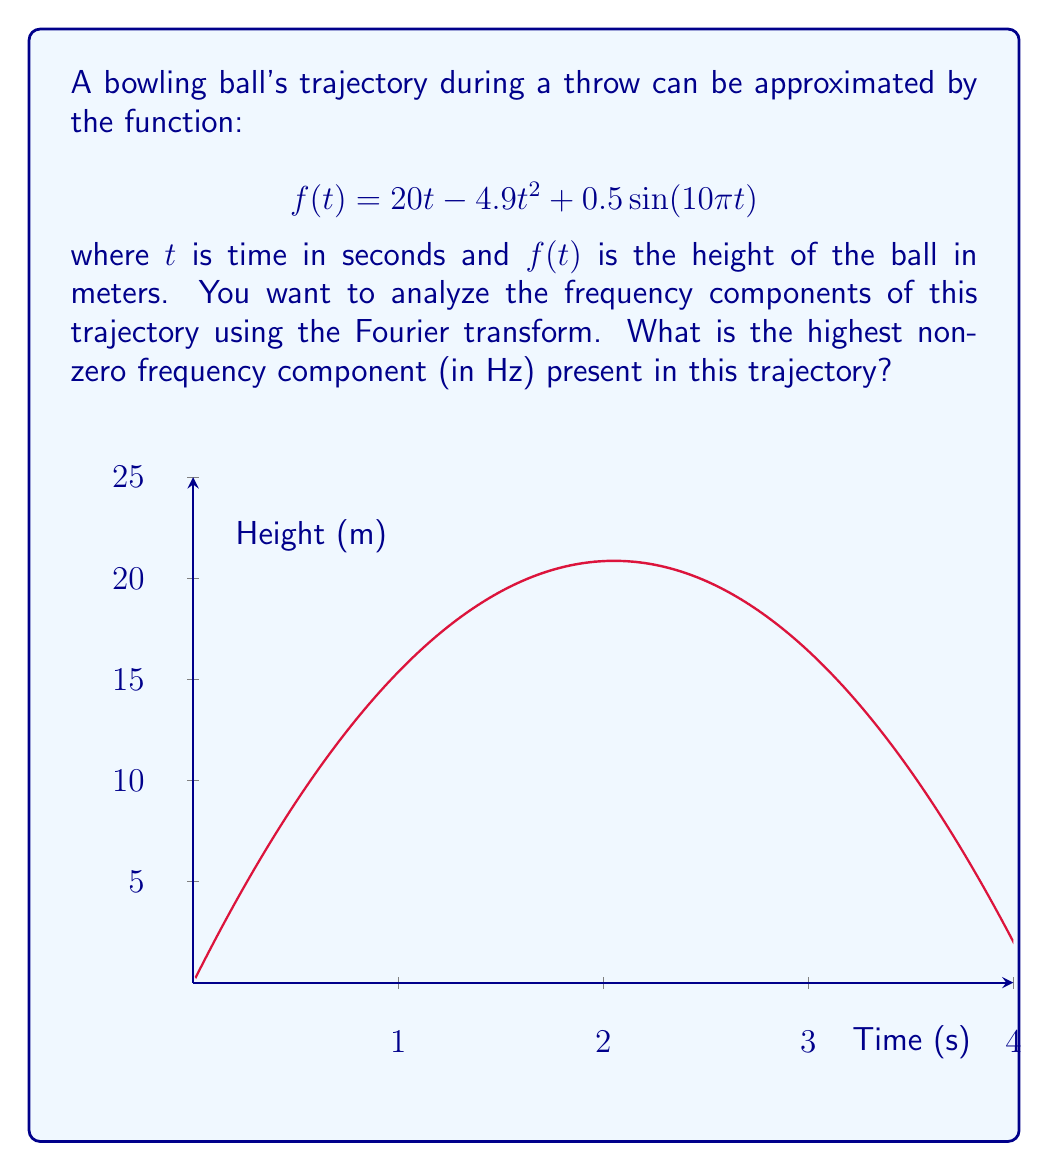Could you help me with this problem? Let's approach this step-by-step:

1) The Fourier transform helps us identify the frequency components in a signal. In this case, our signal is the trajectory function.

2) The trajectory function has three terms:
   - $20t$: This is a linear term, which contributes to the DC (0 Hz) component.
   - $-4.9t^2$: This quadratic term also contributes to low-frequency components.
   - $0.5\sin(10\pi t)$: This is the sinusoidal term that will give us our highest frequency.

3) For a sinusoidal function $\sin(2\pi ft)$, the frequency $f$ is given by the coefficient of $t$ divided by $2\pi$.

4) In our case, we have $\sin(10\pi t)$. Comparing this to the standard form:

   $\sin(10\pi t) = \sin(2\pi (5) t)$

5) Therefore, the frequency of this sinusoidal component is 5 Hz.

6) The linear and quadratic terms don't introduce any higher frequencies, so 5 Hz remains the highest frequency component.
Answer: 5 Hz 